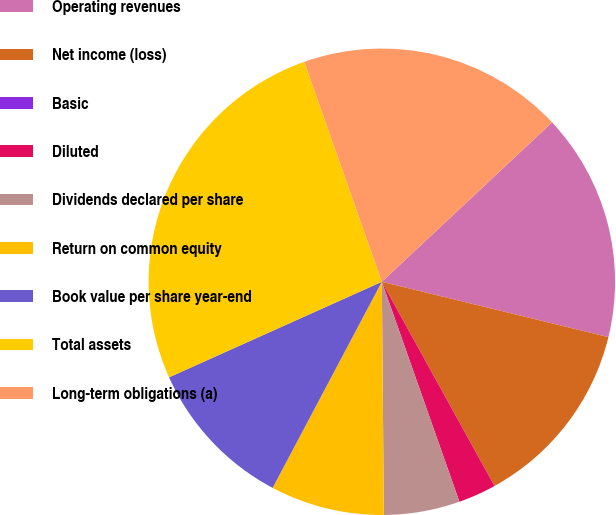Convert chart. <chart><loc_0><loc_0><loc_500><loc_500><pie_chart><fcel>Operating revenues<fcel>Net income (loss)<fcel>Basic<fcel>Diluted<fcel>Dividends declared per share<fcel>Return on common equity<fcel>Book value per share year-end<fcel>Total assets<fcel>Long-term obligations (a)<nl><fcel>15.79%<fcel>13.16%<fcel>0.0%<fcel>2.63%<fcel>5.26%<fcel>7.89%<fcel>10.53%<fcel>26.32%<fcel>18.42%<nl></chart> 